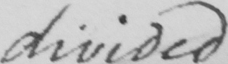Can you tell me what this handwritten text says? divided 